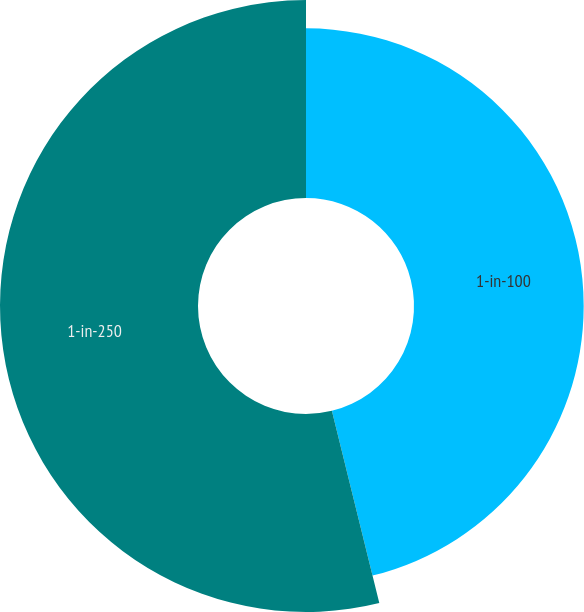Convert chart to OTSL. <chart><loc_0><loc_0><loc_500><loc_500><pie_chart><fcel>1-in-100<fcel>1-in-250<nl><fcel>46.15%<fcel>53.85%<nl></chart> 